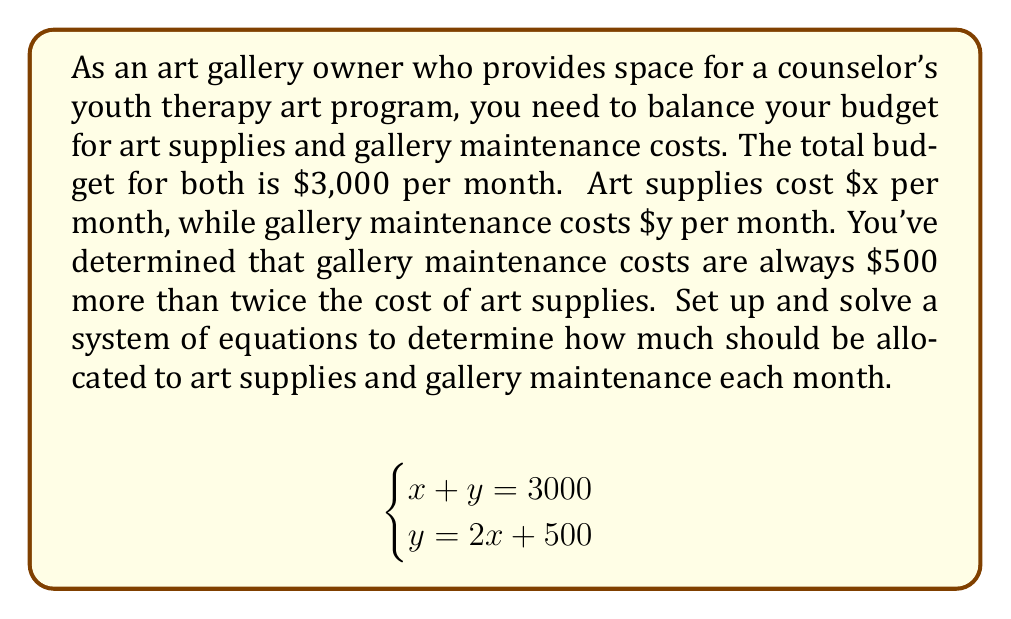What is the answer to this math problem? Let's solve this system of equations using the substitution method:

1) From the second equation, we have:
   $y = 2x + 500$

2) Substitute this into the first equation:
   $x + (2x + 500) = 3000$

3) Simplify:
   $x + 2x + 500 = 3000$
   $3x + 500 = 3000$

4) Subtract 500 from both sides:
   $3x = 2500$

5) Divide both sides by 3:
   $x = \frac{2500}{3} \approx 833.33$

6) Now that we know $x$, we can find $y$ using the second equation:
   $y = 2(\frac{2500}{3}) + 500$
   $y = \frac{5000}{3} + 500$
   $y = \frac{5000}{3} + \frac{1500}{3}$
   $y = \frac{6500}{3} \approx 2166.67$

7) Verify the solution by checking if it satisfies both equations:
   $x + y = 833.33 + 2166.67 = 3000$ (✓)
   $2166.67 = 2(833.33) + 500 = 2166.66$ (✓ allowing for rounding error)
Answer: Art supplies (x): $\frac{2500}{3} \approx $833.33 per month
Gallery maintenance (y): $\frac{6500}{3} \approx $2166.67 per month 